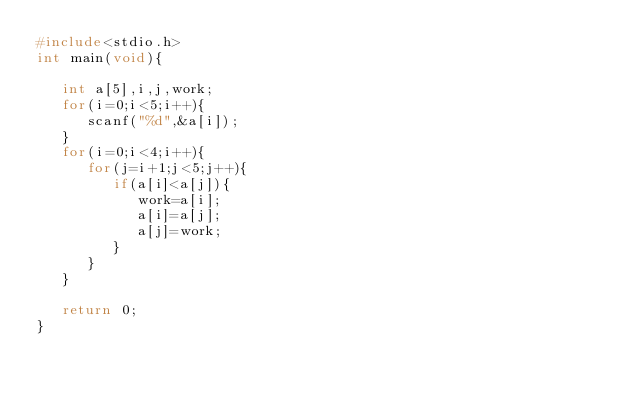Convert code to text. <code><loc_0><loc_0><loc_500><loc_500><_C_>#include<stdio.h>
int main(void){
   
   int a[5],i,j,work;
   for(i=0;i<5;i++){
      scanf("%d",&a[i]);
   }
   for(i=0;i<4;i++){
      for(j=i+1;j<5;j++){
         if(a[i]<a[j]){
            work=a[i];
            a[i]=a[j];
            a[j]=work;
         }
      }
   }

   return 0;
}</code> 